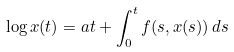<formula> <loc_0><loc_0><loc_500><loc_500>\log x ( t ) = a t + \int _ { 0 } ^ { t } f ( s , x ( s ) ) \, d s</formula> 